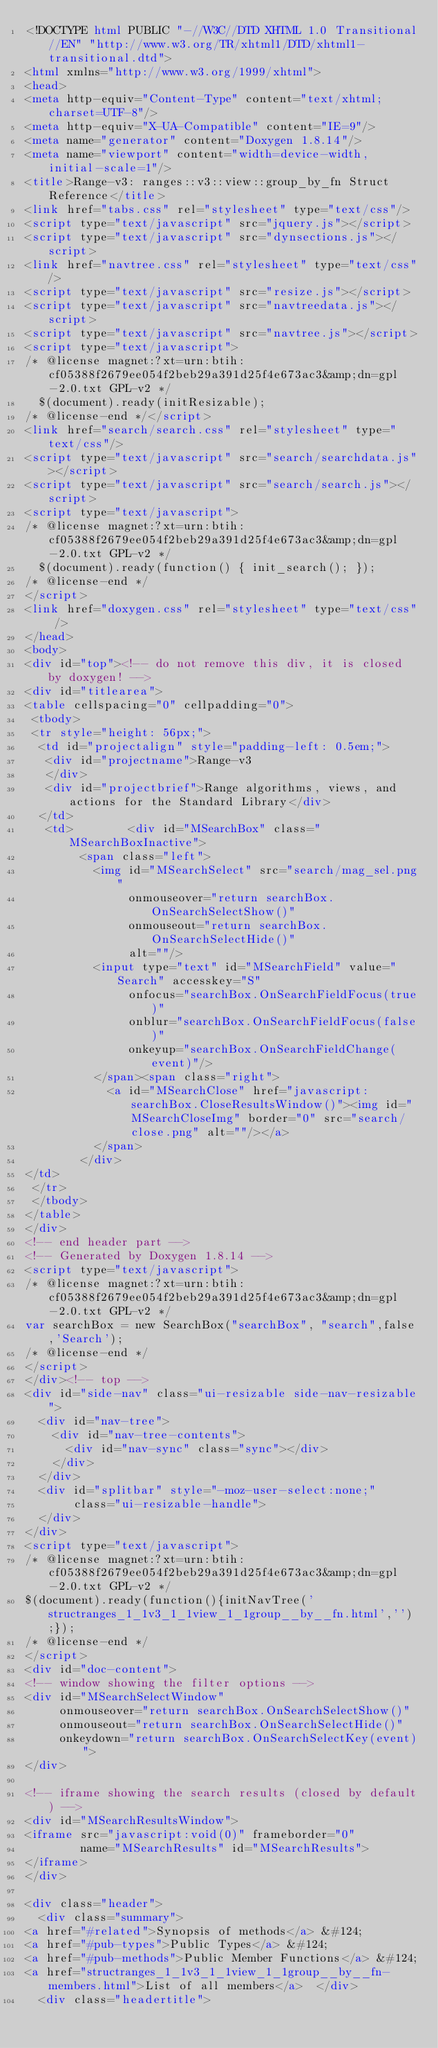Convert code to text. <code><loc_0><loc_0><loc_500><loc_500><_HTML_><!DOCTYPE html PUBLIC "-//W3C//DTD XHTML 1.0 Transitional//EN" "http://www.w3.org/TR/xhtml1/DTD/xhtml1-transitional.dtd">
<html xmlns="http://www.w3.org/1999/xhtml">
<head>
<meta http-equiv="Content-Type" content="text/xhtml;charset=UTF-8"/>
<meta http-equiv="X-UA-Compatible" content="IE=9"/>
<meta name="generator" content="Doxygen 1.8.14"/>
<meta name="viewport" content="width=device-width, initial-scale=1"/>
<title>Range-v3: ranges::v3::view::group_by_fn Struct Reference</title>
<link href="tabs.css" rel="stylesheet" type="text/css"/>
<script type="text/javascript" src="jquery.js"></script>
<script type="text/javascript" src="dynsections.js"></script>
<link href="navtree.css" rel="stylesheet" type="text/css"/>
<script type="text/javascript" src="resize.js"></script>
<script type="text/javascript" src="navtreedata.js"></script>
<script type="text/javascript" src="navtree.js"></script>
<script type="text/javascript">
/* @license magnet:?xt=urn:btih:cf05388f2679ee054f2beb29a391d25f4e673ac3&amp;dn=gpl-2.0.txt GPL-v2 */
  $(document).ready(initResizable);
/* @license-end */</script>
<link href="search/search.css" rel="stylesheet" type="text/css"/>
<script type="text/javascript" src="search/searchdata.js"></script>
<script type="text/javascript" src="search/search.js"></script>
<script type="text/javascript">
/* @license magnet:?xt=urn:btih:cf05388f2679ee054f2beb29a391d25f4e673ac3&amp;dn=gpl-2.0.txt GPL-v2 */
  $(document).ready(function() { init_search(); });
/* @license-end */
</script>
<link href="doxygen.css" rel="stylesheet" type="text/css" />
</head>
<body>
<div id="top"><!-- do not remove this div, it is closed by doxygen! -->
<div id="titlearea">
<table cellspacing="0" cellpadding="0">
 <tbody>
 <tr style="height: 56px;">
  <td id="projectalign" style="padding-left: 0.5em;">
   <div id="projectname">Range-v3
   </div>
   <div id="projectbrief">Range algorithms, views, and actions for the Standard Library</div>
  </td>
   <td>        <div id="MSearchBox" class="MSearchBoxInactive">
        <span class="left">
          <img id="MSearchSelect" src="search/mag_sel.png"
               onmouseover="return searchBox.OnSearchSelectShow()"
               onmouseout="return searchBox.OnSearchSelectHide()"
               alt=""/>
          <input type="text" id="MSearchField" value="Search" accesskey="S"
               onfocus="searchBox.OnSearchFieldFocus(true)" 
               onblur="searchBox.OnSearchFieldFocus(false)" 
               onkeyup="searchBox.OnSearchFieldChange(event)"/>
          </span><span class="right">
            <a id="MSearchClose" href="javascript:searchBox.CloseResultsWindow()"><img id="MSearchCloseImg" border="0" src="search/close.png" alt=""/></a>
          </span>
        </div>
</td>
 </tr>
 </tbody>
</table>
</div>
<!-- end header part -->
<!-- Generated by Doxygen 1.8.14 -->
<script type="text/javascript">
/* @license magnet:?xt=urn:btih:cf05388f2679ee054f2beb29a391d25f4e673ac3&amp;dn=gpl-2.0.txt GPL-v2 */
var searchBox = new SearchBox("searchBox", "search",false,'Search');
/* @license-end */
</script>
</div><!-- top -->
<div id="side-nav" class="ui-resizable side-nav-resizable">
  <div id="nav-tree">
    <div id="nav-tree-contents">
      <div id="nav-sync" class="sync"></div>
    </div>
  </div>
  <div id="splitbar" style="-moz-user-select:none;" 
       class="ui-resizable-handle">
  </div>
</div>
<script type="text/javascript">
/* @license magnet:?xt=urn:btih:cf05388f2679ee054f2beb29a391d25f4e673ac3&amp;dn=gpl-2.0.txt GPL-v2 */
$(document).ready(function(){initNavTree('structranges_1_1v3_1_1view_1_1group__by__fn.html','');});
/* @license-end */
</script>
<div id="doc-content">
<!-- window showing the filter options -->
<div id="MSearchSelectWindow"
     onmouseover="return searchBox.OnSearchSelectShow()"
     onmouseout="return searchBox.OnSearchSelectHide()"
     onkeydown="return searchBox.OnSearchSelectKey(event)">
</div>

<!-- iframe showing the search results (closed by default) -->
<div id="MSearchResultsWindow">
<iframe src="javascript:void(0)" frameborder="0" 
        name="MSearchResults" id="MSearchResults">
</iframe>
</div>

<div class="header">
  <div class="summary">
<a href="#related">Synopsis of methods</a> &#124;
<a href="#pub-types">Public Types</a> &#124;
<a href="#pub-methods">Public Member Functions</a> &#124;
<a href="structranges_1_1v3_1_1view_1_1group__by__fn-members.html">List of all members</a>  </div>
  <div class="headertitle"></code> 